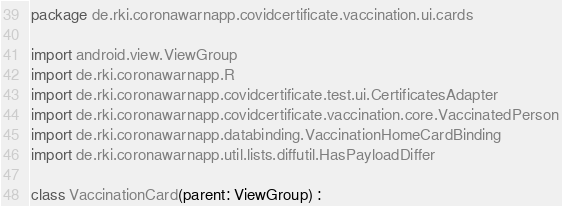<code> <loc_0><loc_0><loc_500><loc_500><_Kotlin_>package de.rki.coronawarnapp.covidcertificate.vaccination.ui.cards

import android.view.ViewGroup
import de.rki.coronawarnapp.R
import de.rki.coronawarnapp.covidcertificate.test.ui.CertificatesAdapter
import de.rki.coronawarnapp.covidcertificate.vaccination.core.VaccinatedPerson
import de.rki.coronawarnapp.databinding.VaccinationHomeCardBinding
import de.rki.coronawarnapp.util.lists.diffutil.HasPayloadDiffer

class VaccinationCard(parent: ViewGroup) :</code> 